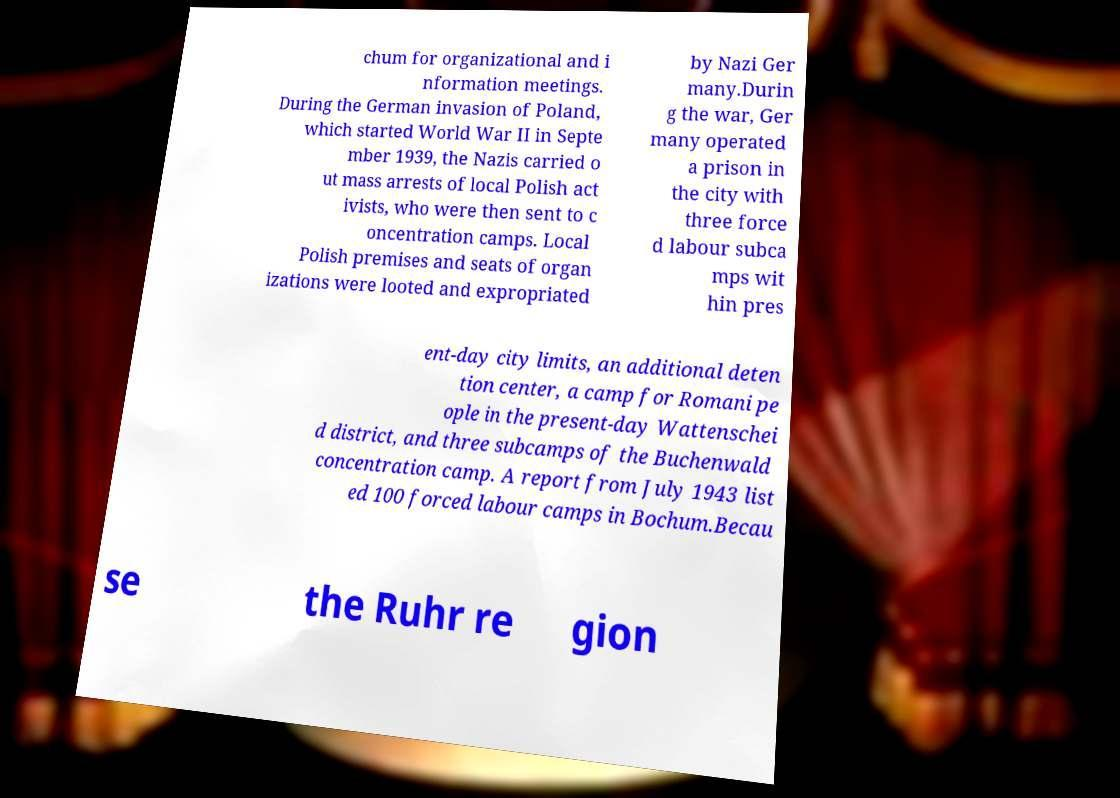Could you extract and type out the text from this image? chum for organizational and i nformation meetings. During the German invasion of Poland, which started World War II in Septe mber 1939, the Nazis carried o ut mass arrests of local Polish act ivists, who were then sent to c oncentration camps. Local Polish premises and seats of organ izations were looted and expropriated by Nazi Ger many.Durin g the war, Ger many operated a prison in the city with three force d labour subca mps wit hin pres ent-day city limits, an additional deten tion center, a camp for Romani pe ople in the present-day Wattenschei d district, and three subcamps of the Buchenwald concentration camp. A report from July 1943 list ed 100 forced labour camps in Bochum.Becau se the Ruhr re gion 